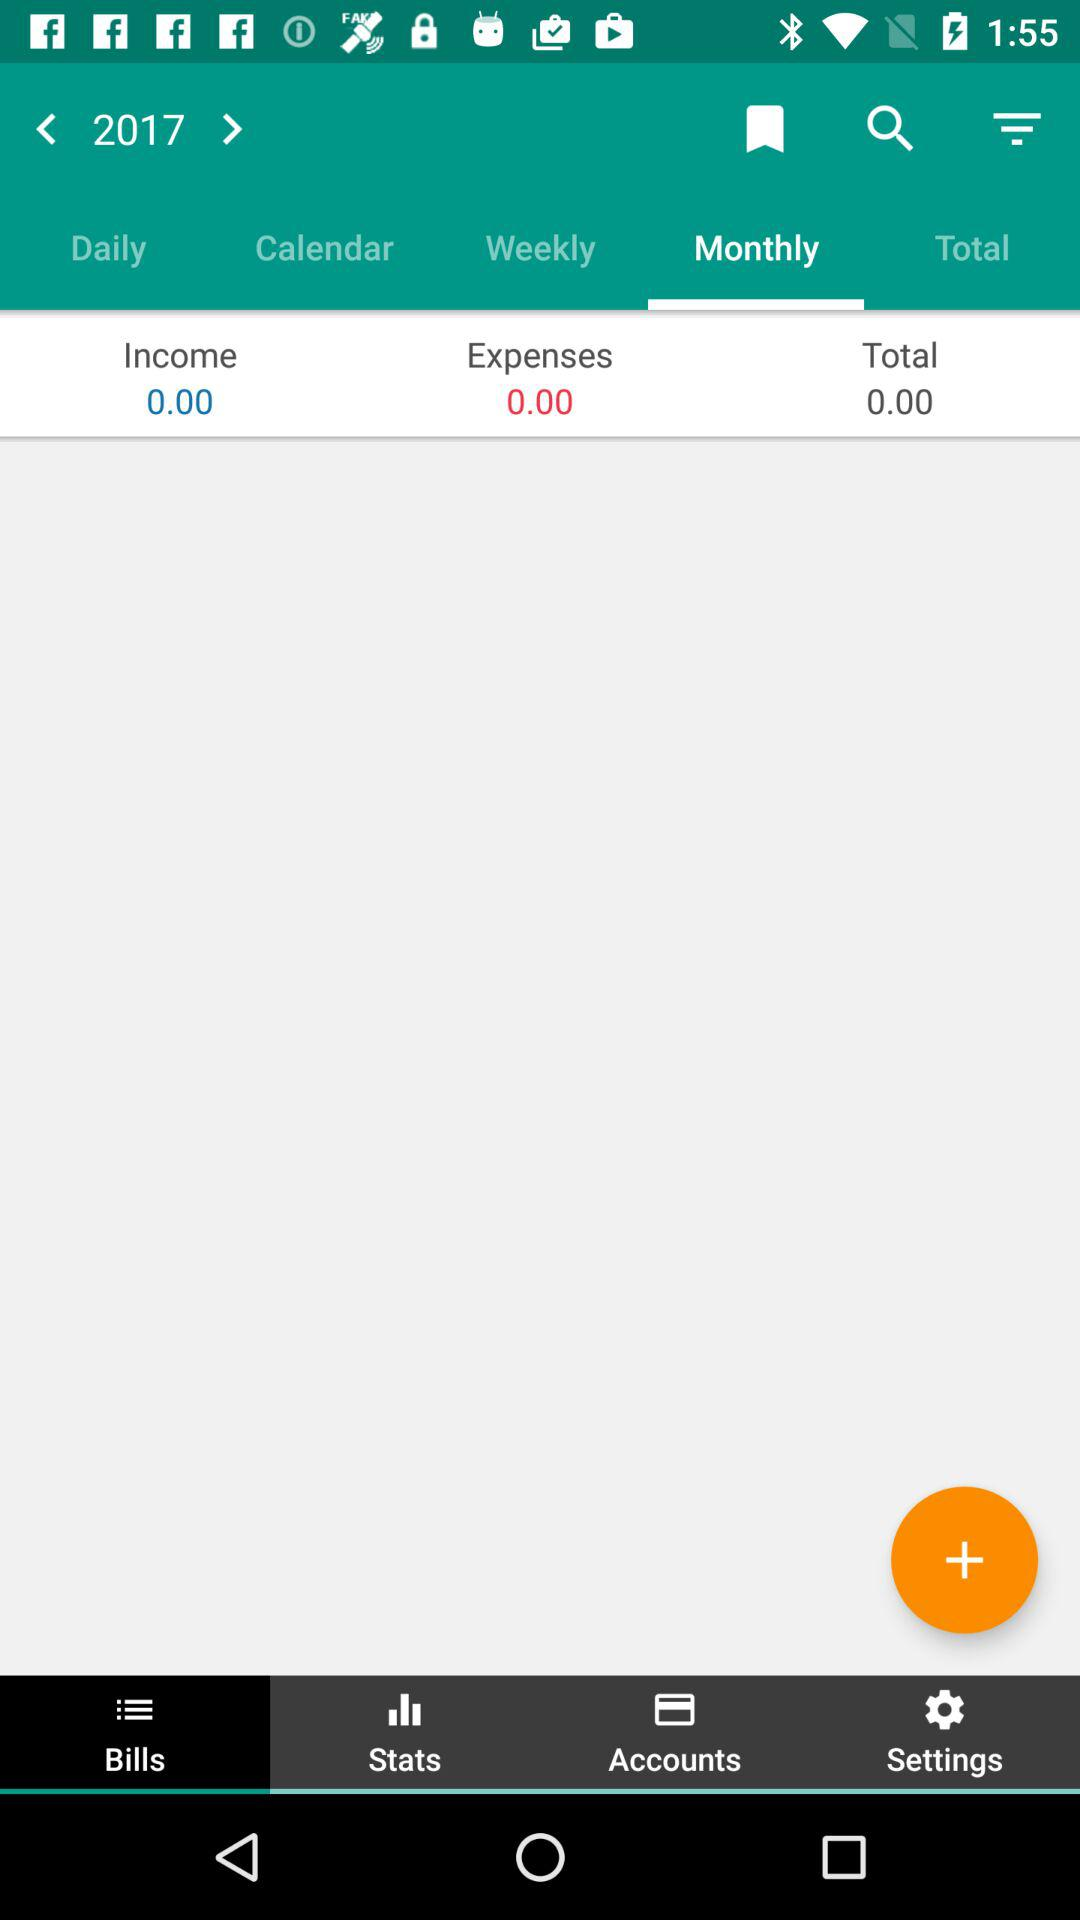How much is the "Total"? The "Total" is 0.00. 